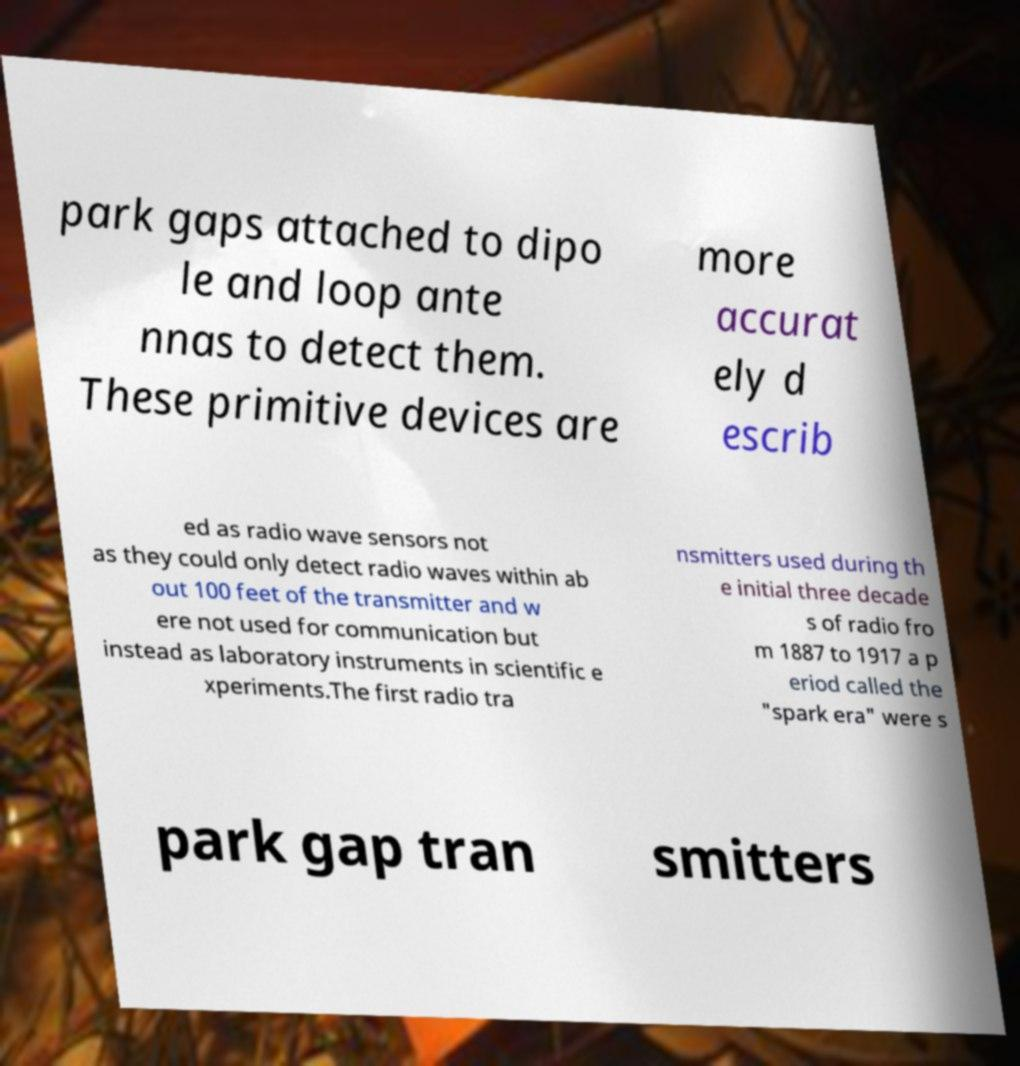Could you extract and type out the text from this image? park gaps attached to dipo le and loop ante nnas to detect them. These primitive devices are more accurat ely d escrib ed as radio wave sensors not as they could only detect radio waves within ab out 100 feet of the transmitter and w ere not used for communication but instead as laboratory instruments in scientific e xperiments.The first radio tra nsmitters used during th e initial three decade s of radio fro m 1887 to 1917 a p eriod called the "spark era" were s park gap tran smitters 